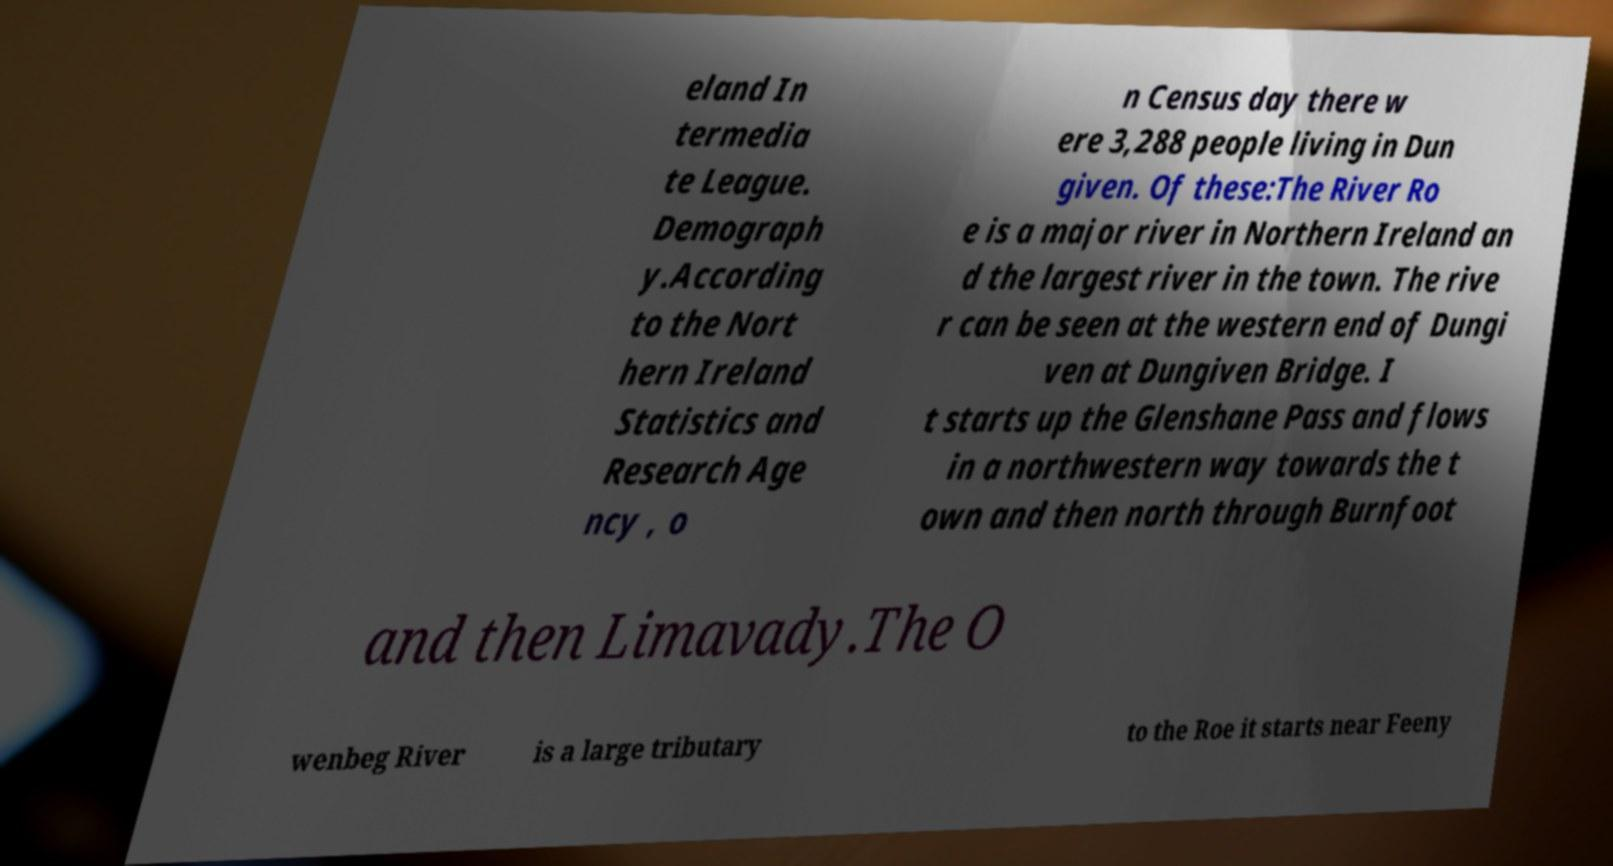For documentation purposes, I need the text within this image transcribed. Could you provide that? eland In termedia te League. Demograph y.According to the Nort hern Ireland Statistics and Research Age ncy , o n Census day there w ere 3,288 people living in Dun given. Of these:The River Ro e is a major river in Northern Ireland an d the largest river in the town. The rive r can be seen at the western end of Dungi ven at Dungiven Bridge. I t starts up the Glenshane Pass and flows in a northwestern way towards the t own and then north through Burnfoot and then Limavady.The O wenbeg River is a large tributary to the Roe it starts near Feeny 